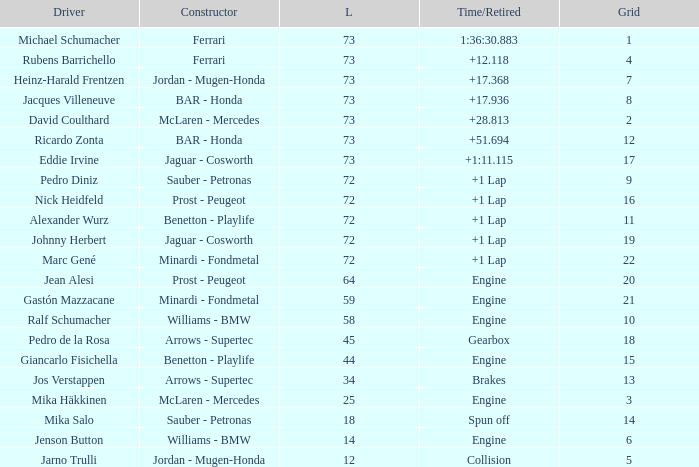How many laps did Jos Verstappen do on Grid 2? 34.0. 